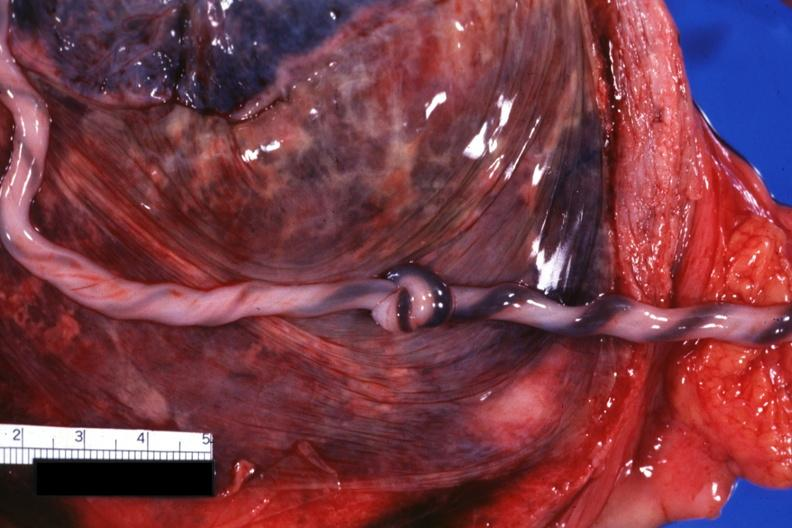s female reproductive present?
Answer the question using a single word or phrase. Yes 